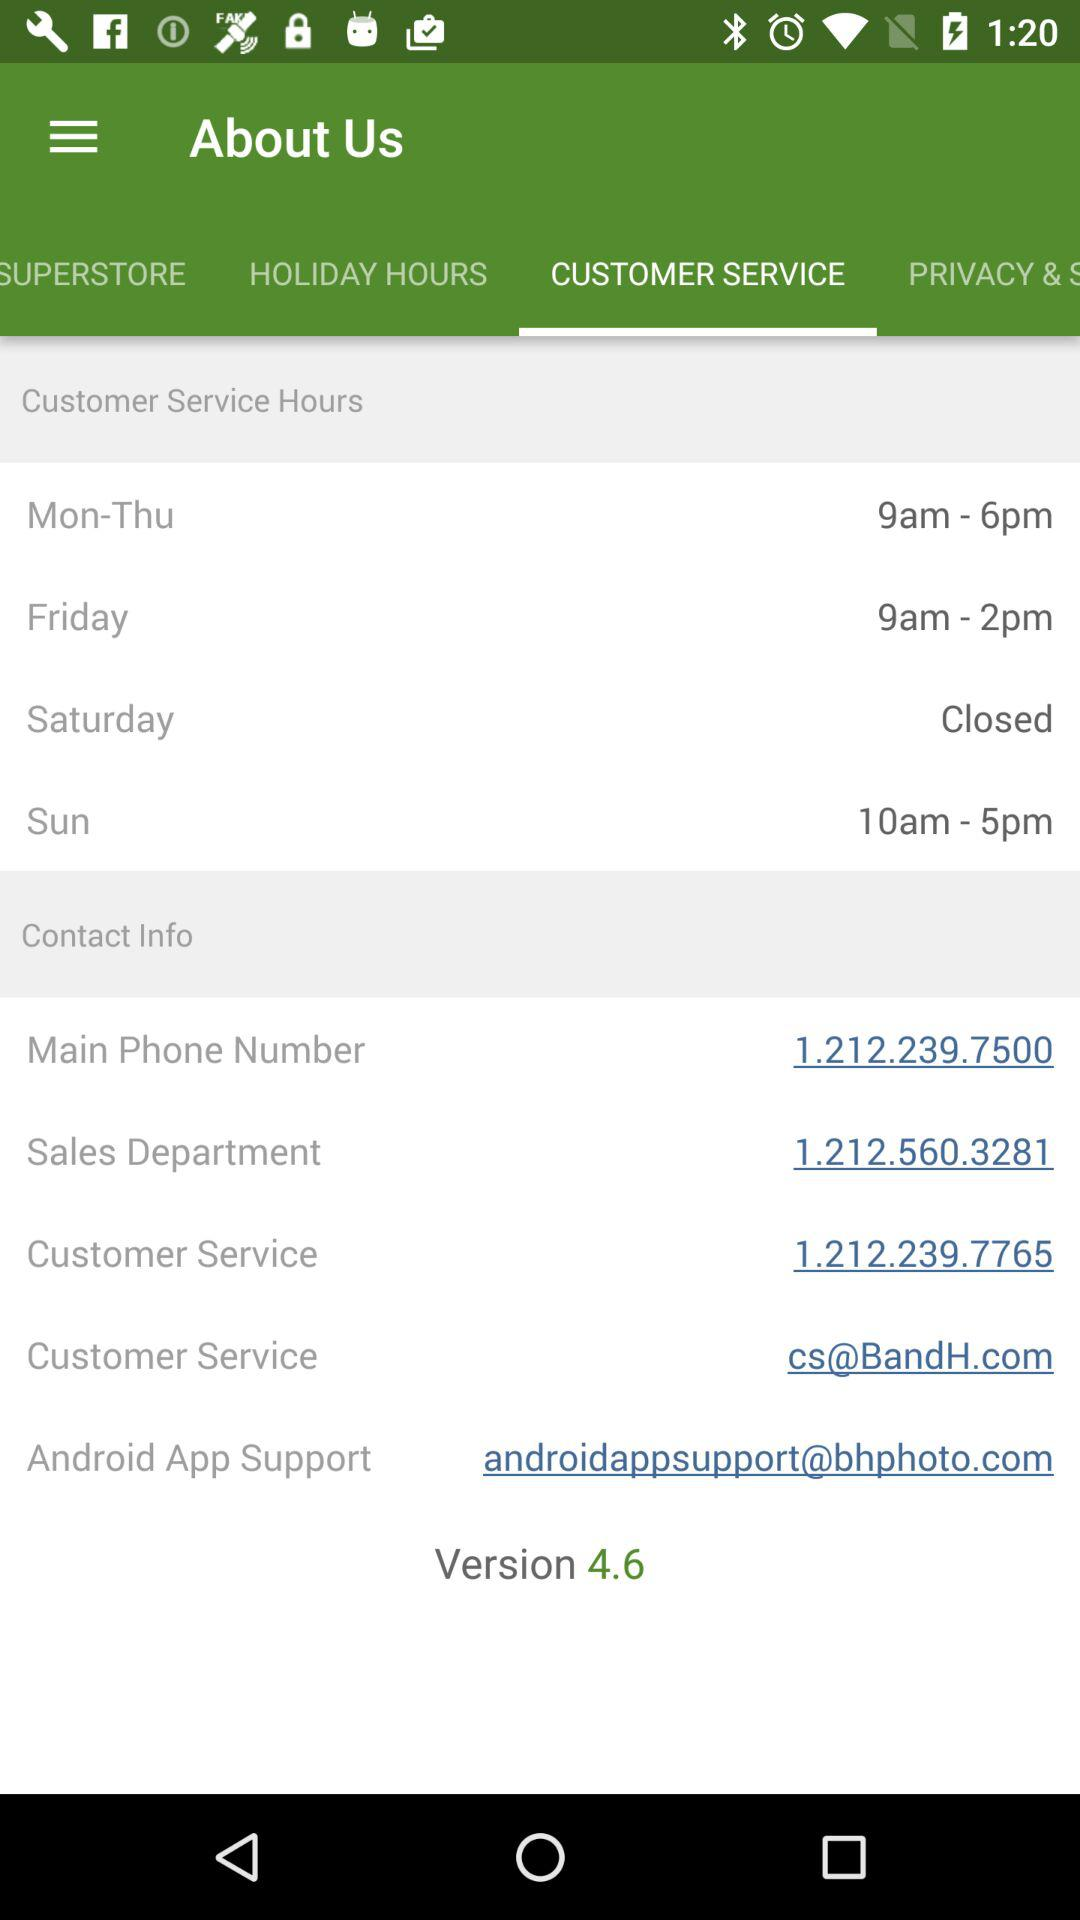What are the customer service hours for Monday through Thursday? The customer service hours for Monday through Thursday are 9 a.m. to 6 p.m. 